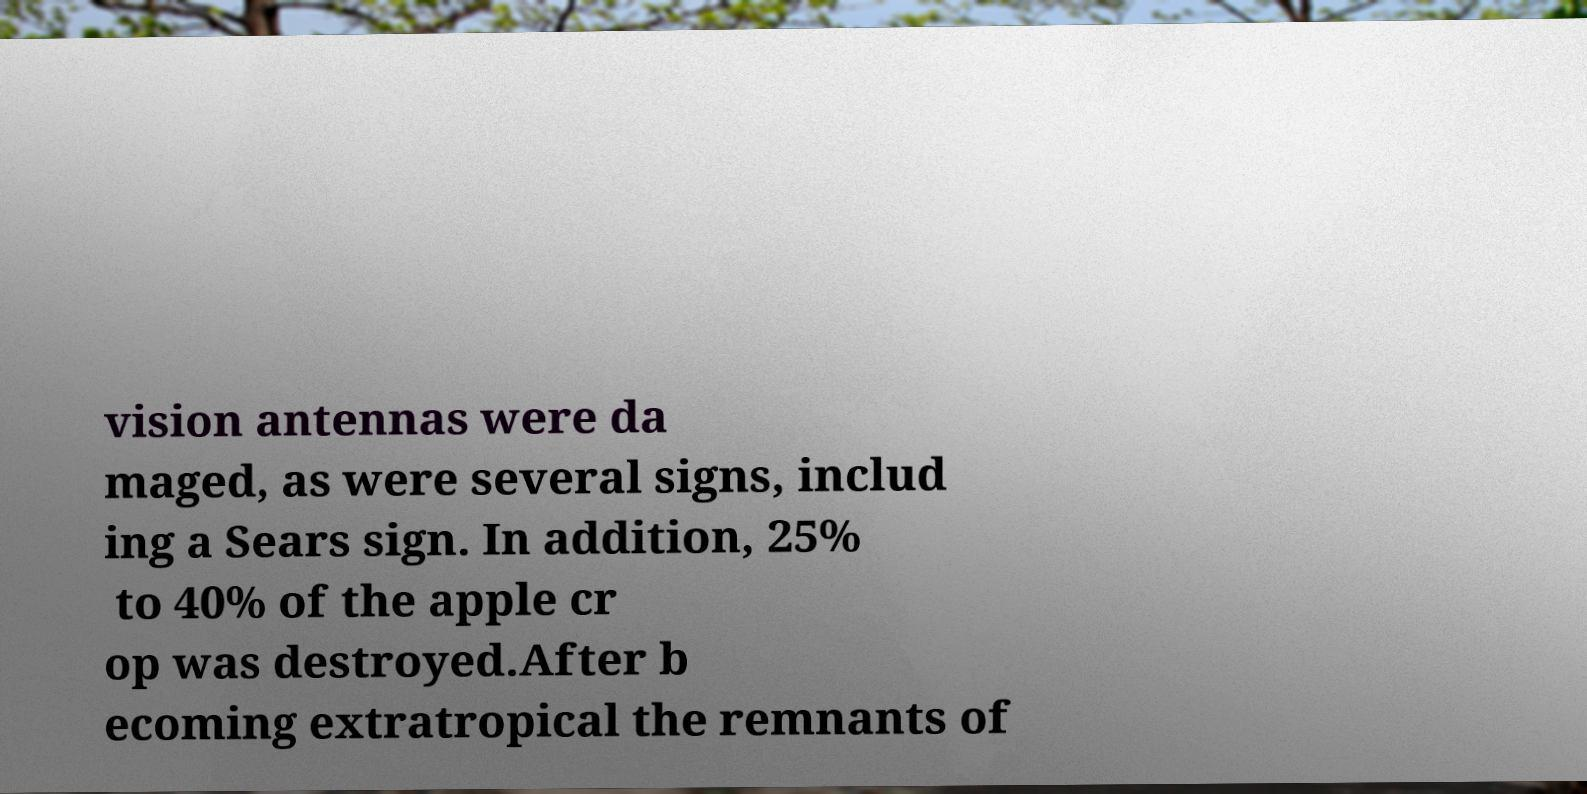Could you assist in decoding the text presented in this image and type it out clearly? vision antennas were da maged, as were several signs, includ ing a Sears sign. In addition, 25% to 40% of the apple cr op was destroyed.After b ecoming extratropical the remnants of 